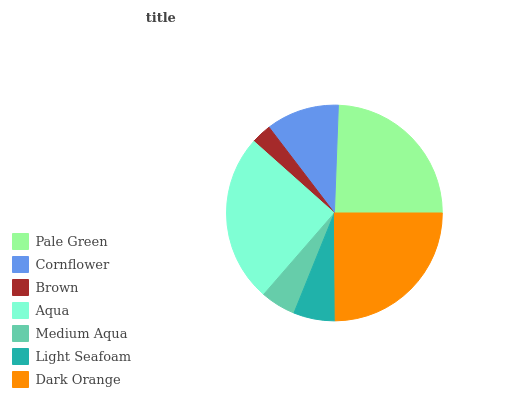Is Brown the minimum?
Answer yes or no. Yes. Is Aqua the maximum?
Answer yes or no. Yes. Is Cornflower the minimum?
Answer yes or no. No. Is Cornflower the maximum?
Answer yes or no. No. Is Pale Green greater than Cornflower?
Answer yes or no. Yes. Is Cornflower less than Pale Green?
Answer yes or no. Yes. Is Cornflower greater than Pale Green?
Answer yes or no. No. Is Pale Green less than Cornflower?
Answer yes or no. No. Is Cornflower the high median?
Answer yes or no. Yes. Is Cornflower the low median?
Answer yes or no. Yes. Is Brown the high median?
Answer yes or no. No. Is Medium Aqua the low median?
Answer yes or no. No. 